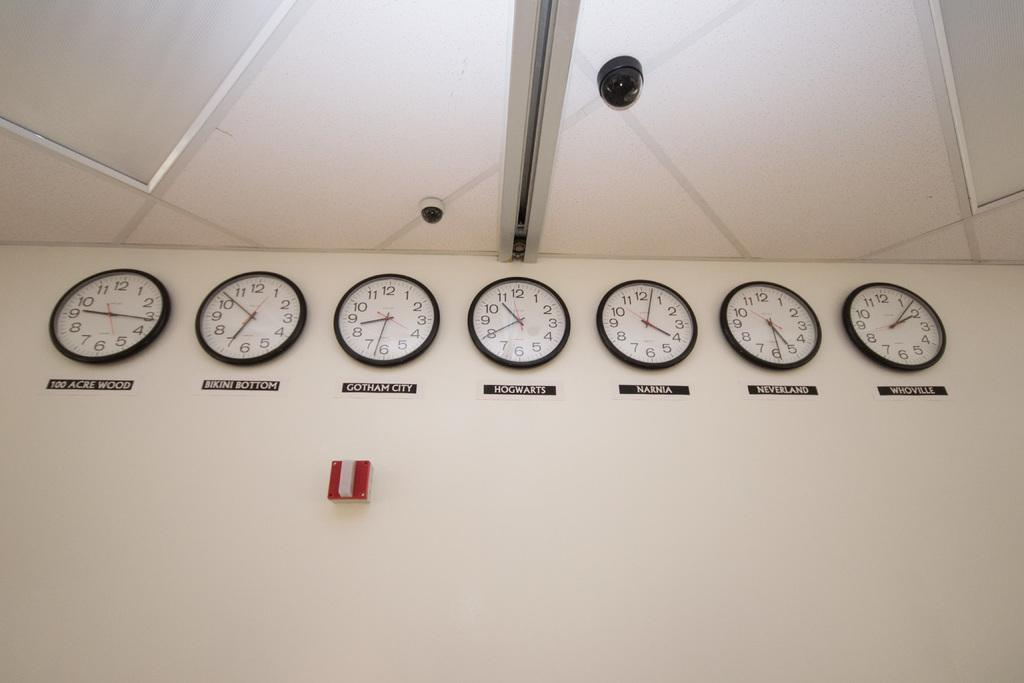Provide a one-sentence caption for the provided image. A bank of clocks on the wall that show the time in fictional places like Bikini Bottom and 100 Acre Woods. 